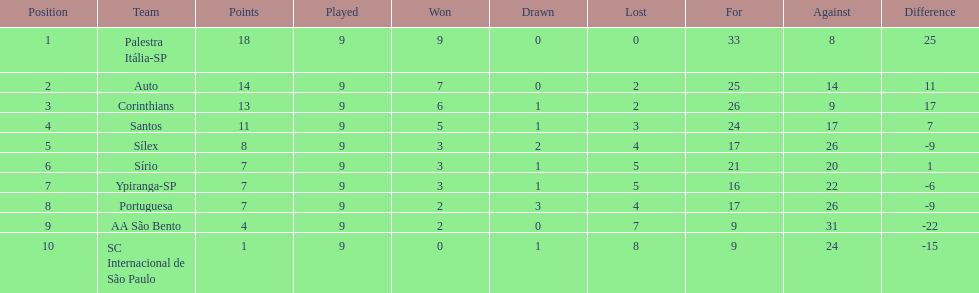During the 1926 football season in brazil, how many points were scored in total? 90. 